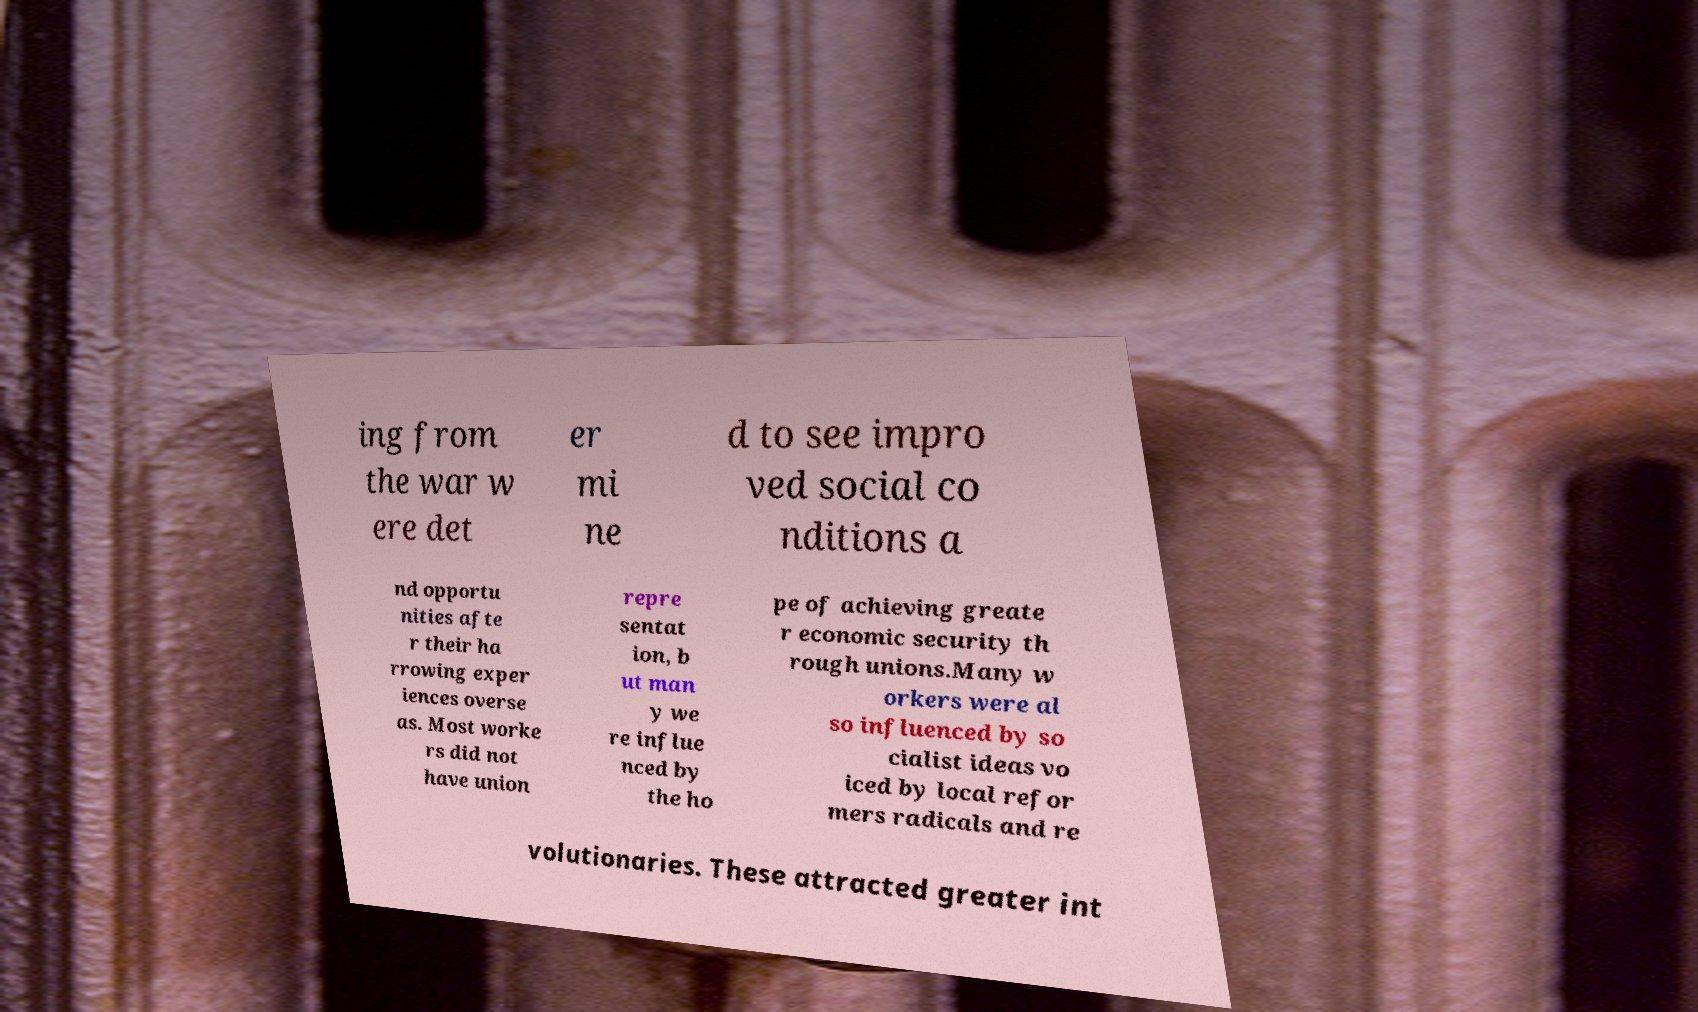Could you assist in decoding the text presented in this image and type it out clearly? ing from the war w ere det er mi ne d to see impro ved social co nditions a nd opportu nities afte r their ha rrowing exper iences overse as. Most worke rs did not have union repre sentat ion, b ut man y we re influe nced by the ho pe of achieving greate r economic security th rough unions.Many w orkers were al so influenced by so cialist ideas vo iced by local refor mers radicals and re volutionaries. These attracted greater int 